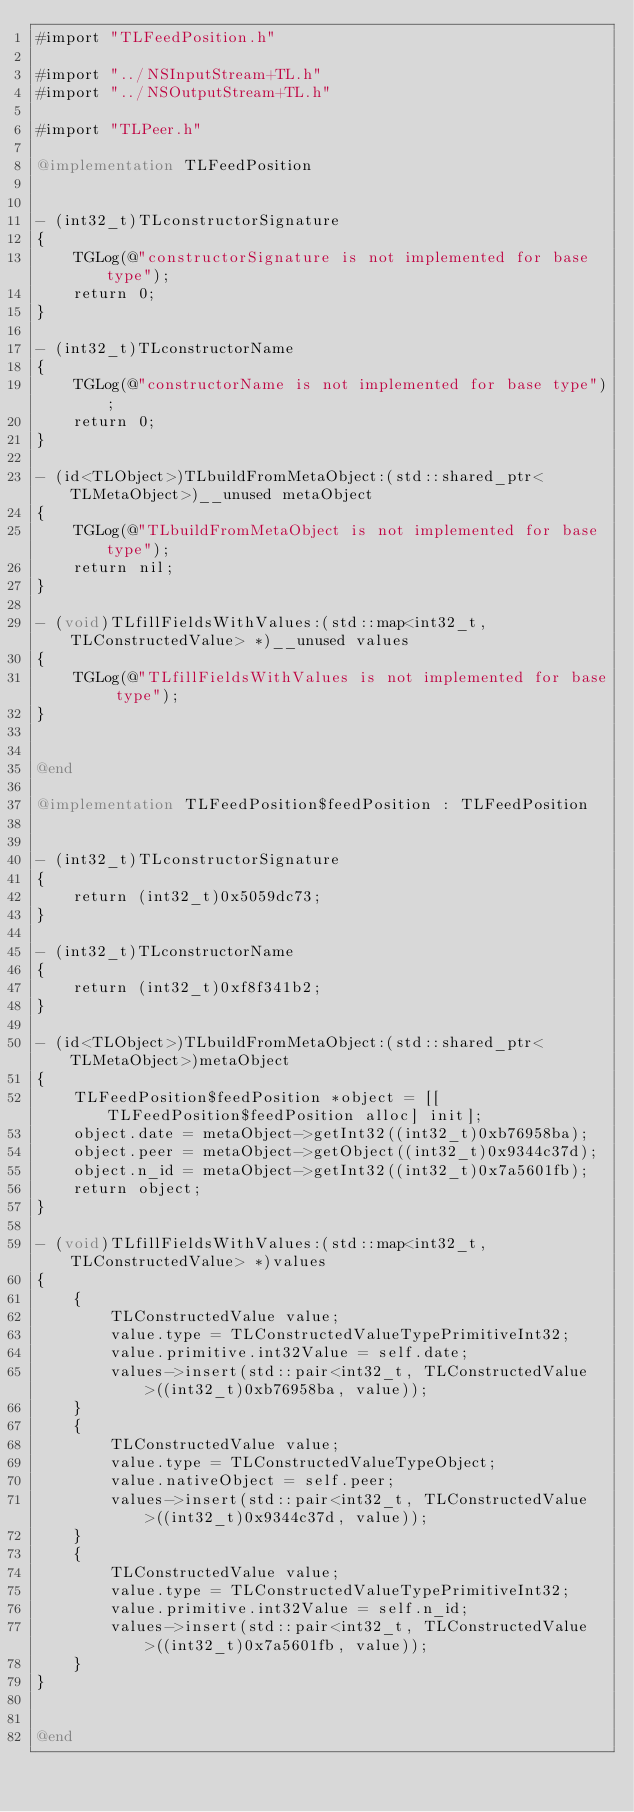<code> <loc_0><loc_0><loc_500><loc_500><_ObjectiveC_>#import "TLFeedPosition.h"

#import "../NSInputStream+TL.h"
#import "../NSOutputStream+TL.h"

#import "TLPeer.h"

@implementation TLFeedPosition


- (int32_t)TLconstructorSignature
{
    TGLog(@"constructorSignature is not implemented for base type");
    return 0;
}

- (int32_t)TLconstructorName
{
    TGLog(@"constructorName is not implemented for base type");
    return 0;
}

- (id<TLObject>)TLbuildFromMetaObject:(std::shared_ptr<TLMetaObject>)__unused metaObject
{
    TGLog(@"TLbuildFromMetaObject is not implemented for base type");
    return nil;
}

- (void)TLfillFieldsWithValues:(std::map<int32_t, TLConstructedValue> *)__unused values
{
    TGLog(@"TLfillFieldsWithValues is not implemented for base type");
}


@end

@implementation TLFeedPosition$feedPosition : TLFeedPosition


- (int32_t)TLconstructorSignature
{
    return (int32_t)0x5059dc73;
}

- (int32_t)TLconstructorName
{
    return (int32_t)0xf8f341b2;
}

- (id<TLObject>)TLbuildFromMetaObject:(std::shared_ptr<TLMetaObject>)metaObject
{
    TLFeedPosition$feedPosition *object = [[TLFeedPosition$feedPosition alloc] init];
    object.date = metaObject->getInt32((int32_t)0xb76958ba);
    object.peer = metaObject->getObject((int32_t)0x9344c37d);
    object.n_id = metaObject->getInt32((int32_t)0x7a5601fb);
    return object;
}

- (void)TLfillFieldsWithValues:(std::map<int32_t, TLConstructedValue> *)values
{
    {
        TLConstructedValue value;
        value.type = TLConstructedValueTypePrimitiveInt32;
        value.primitive.int32Value = self.date;
        values->insert(std::pair<int32_t, TLConstructedValue>((int32_t)0xb76958ba, value));
    }
    {
        TLConstructedValue value;
        value.type = TLConstructedValueTypeObject;
        value.nativeObject = self.peer;
        values->insert(std::pair<int32_t, TLConstructedValue>((int32_t)0x9344c37d, value));
    }
    {
        TLConstructedValue value;
        value.type = TLConstructedValueTypePrimitiveInt32;
        value.primitive.int32Value = self.n_id;
        values->insert(std::pair<int32_t, TLConstructedValue>((int32_t)0x7a5601fb, value));
    }
}


@end
</code> 